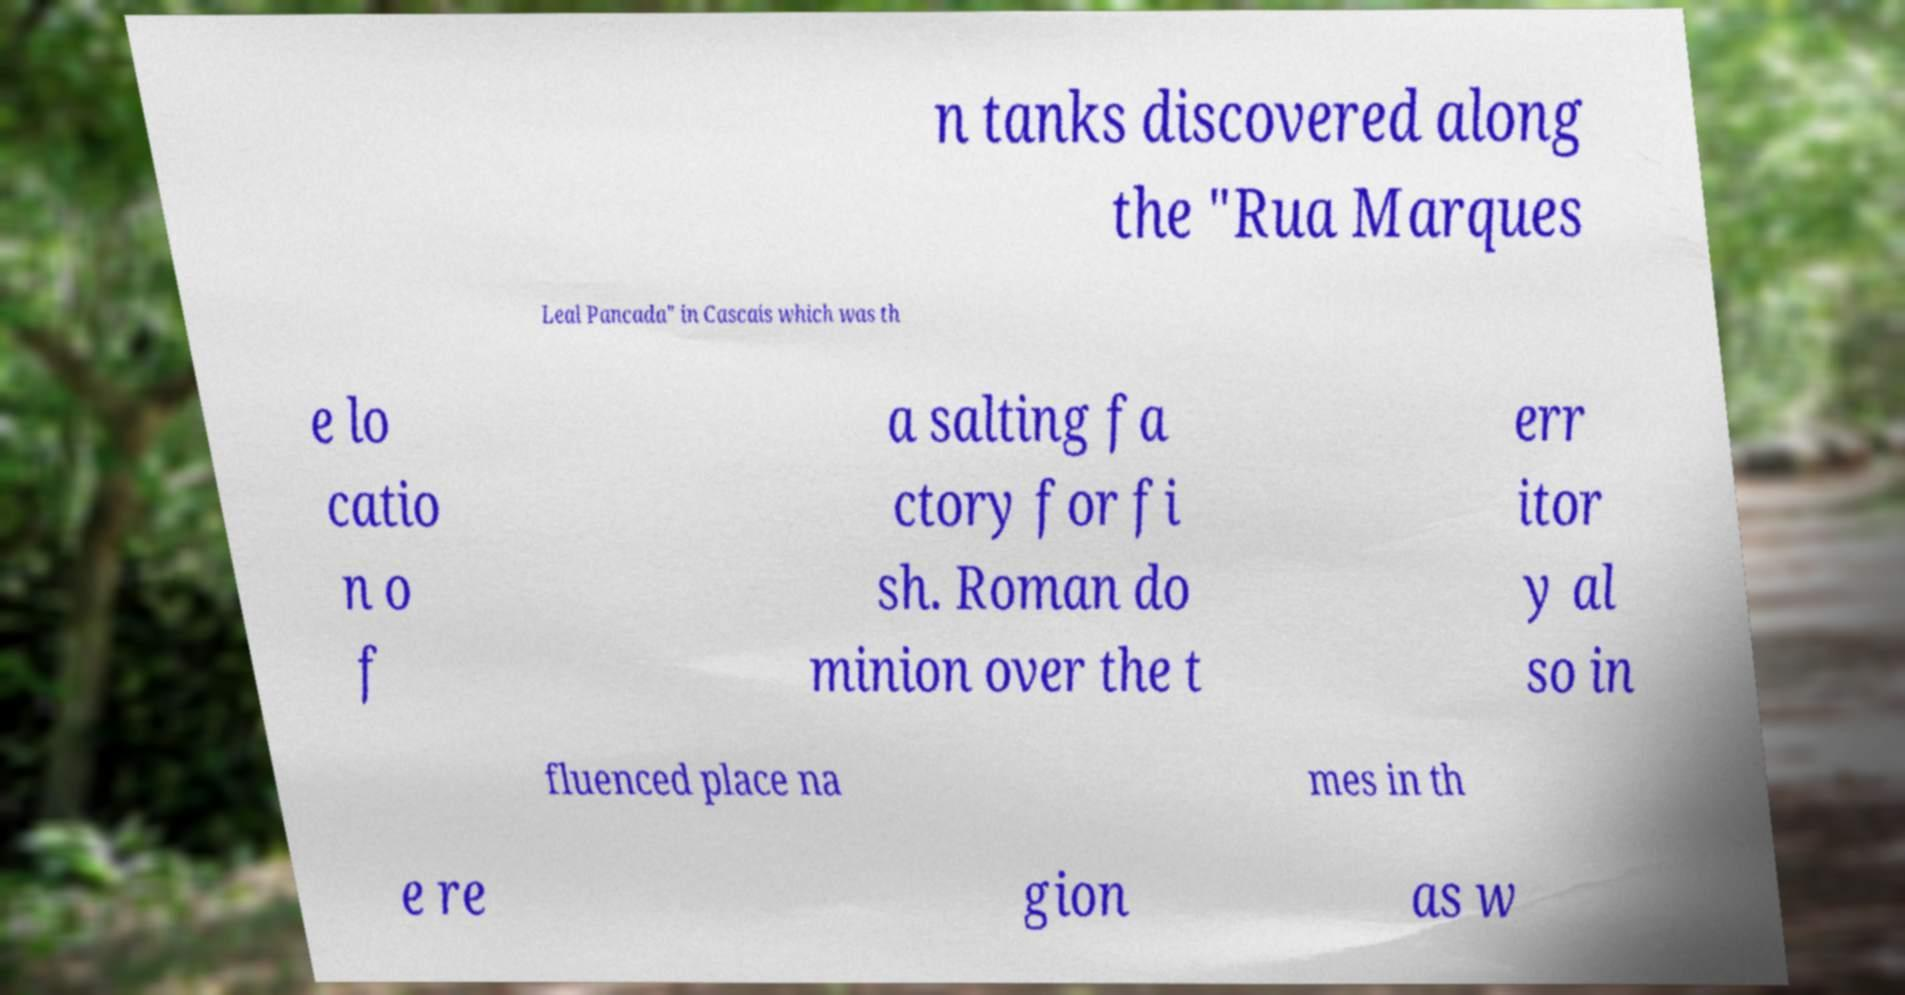I need the written content from this picture converted into text. Can you do that? n tanks discovered along the "Rua Marques Leal Pancada" in Cascais which was th e lo catio n o f a salting fa ctory for fi sh. Roman do minion over the t err itor y al so in fluenced place na mes in th e re gion as w 